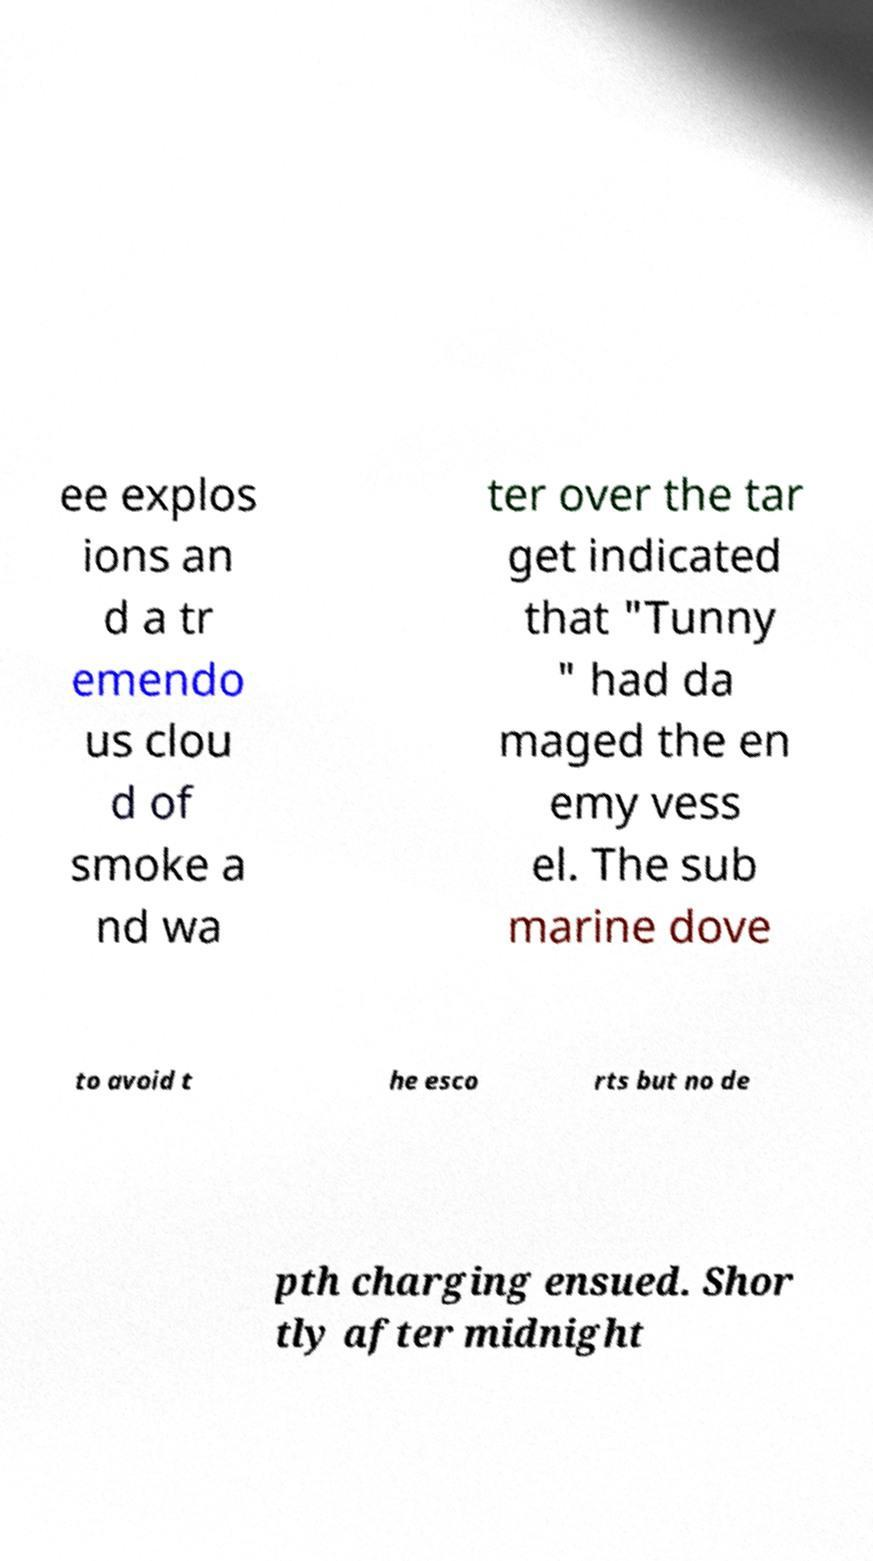Could you extract and type out the text from this image? ee explos ions an d a tr emendo us clou d of smoke a nd wa ter over the tar get indicated that "Tunny " had da maged the en emy vess el. The sub marine dove to avoid t he esco rts but no de pth charging ensued. Shor tly after midnight 